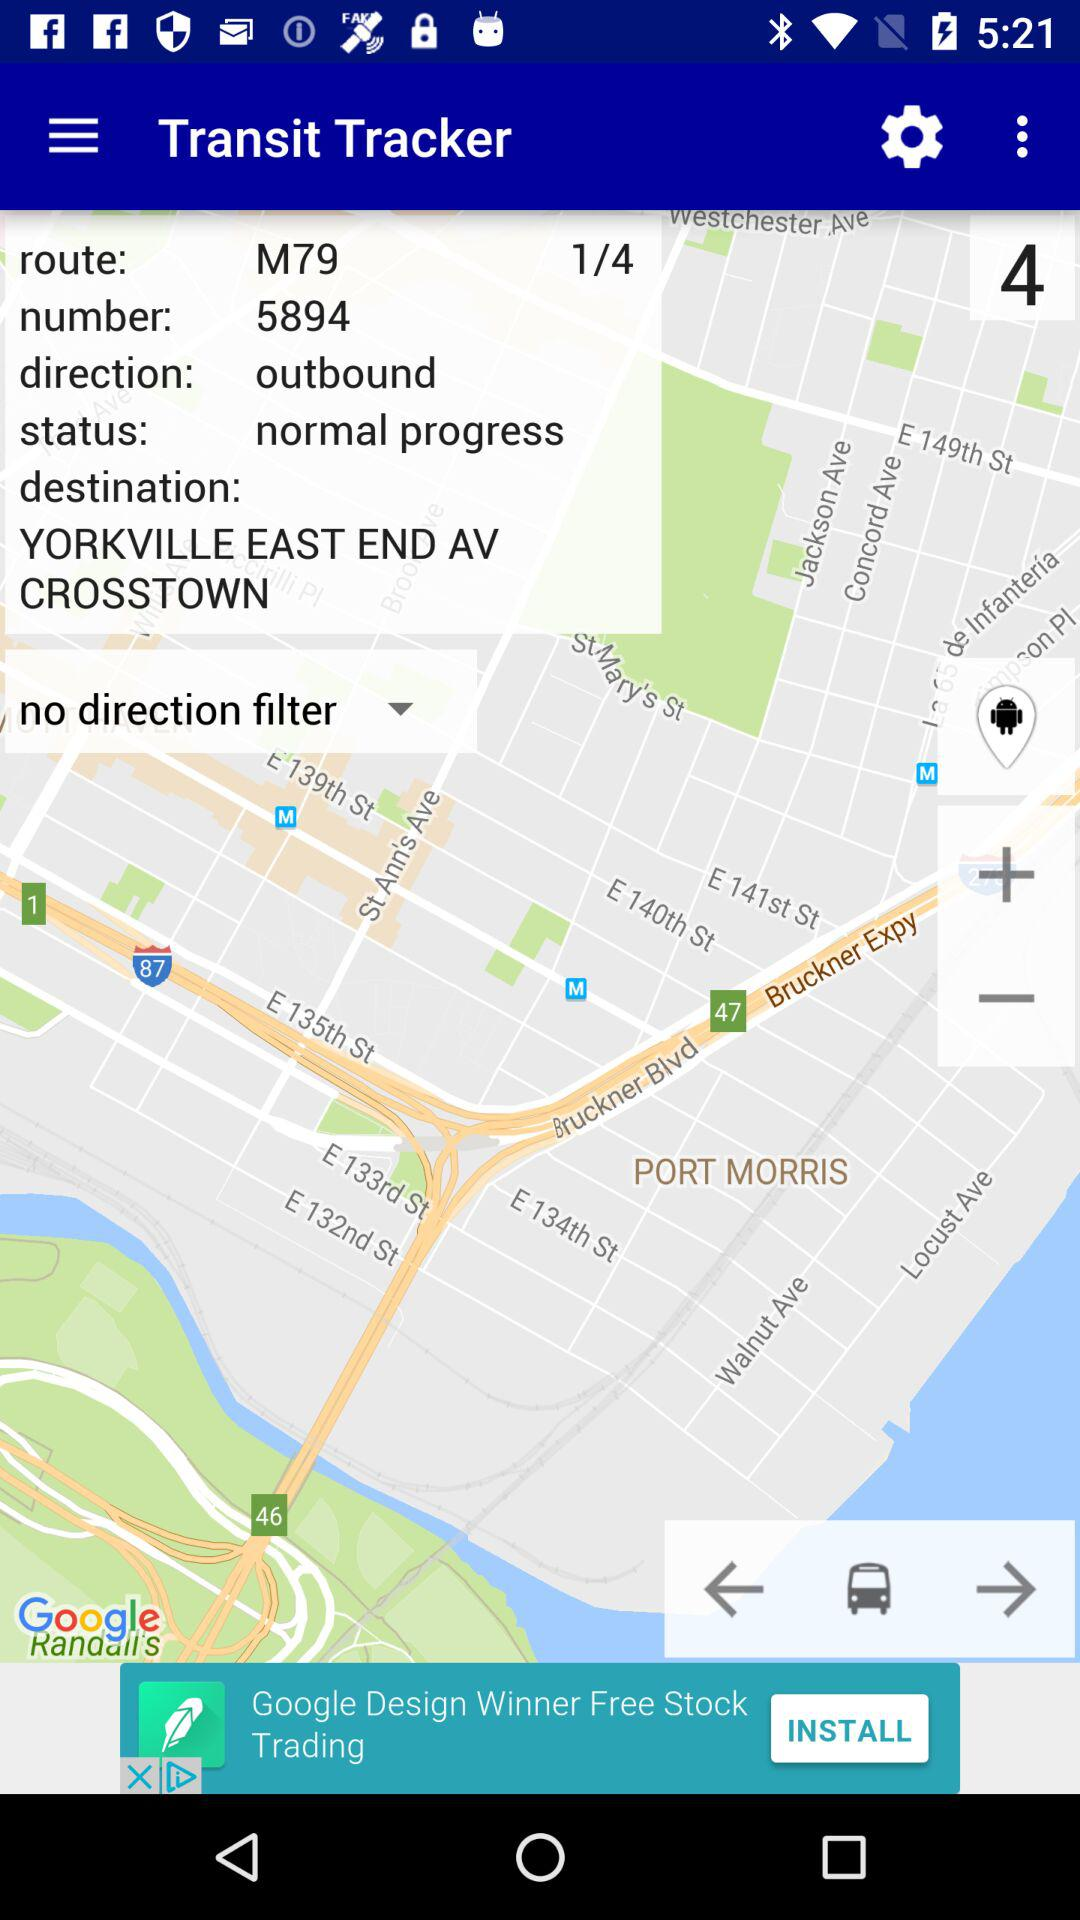What is the given status? The given status is "normal progress". 